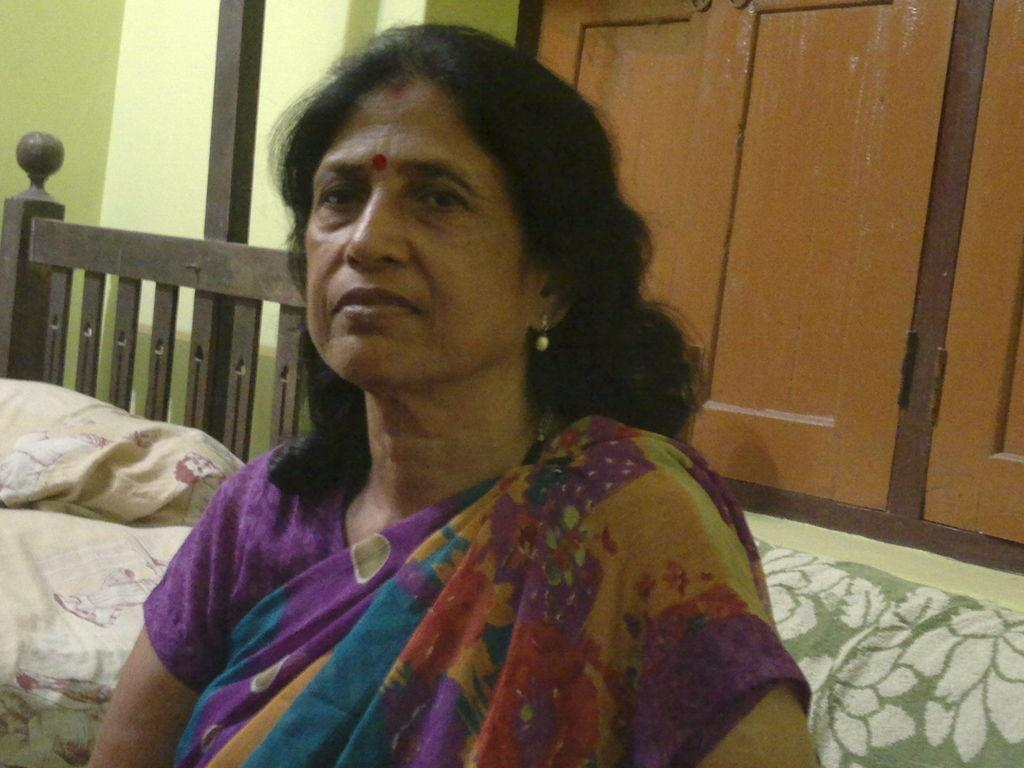What is the main subject of the image? The main subject of the image is a woman. Can you describe the woman's position in the image? The woman is in the center of the image. What is the woman sitting on in the image? The woman is sitting on a sofa. What type of drug can be seen in the woman's hand in the image? There is no drug present in the image; the woman is simply sitting on a sofa. 